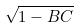Convert formula to latex. <formula><loc_0><loc_0><loc_500><loc_500>\sqrt { 1 - B C }</formula> 